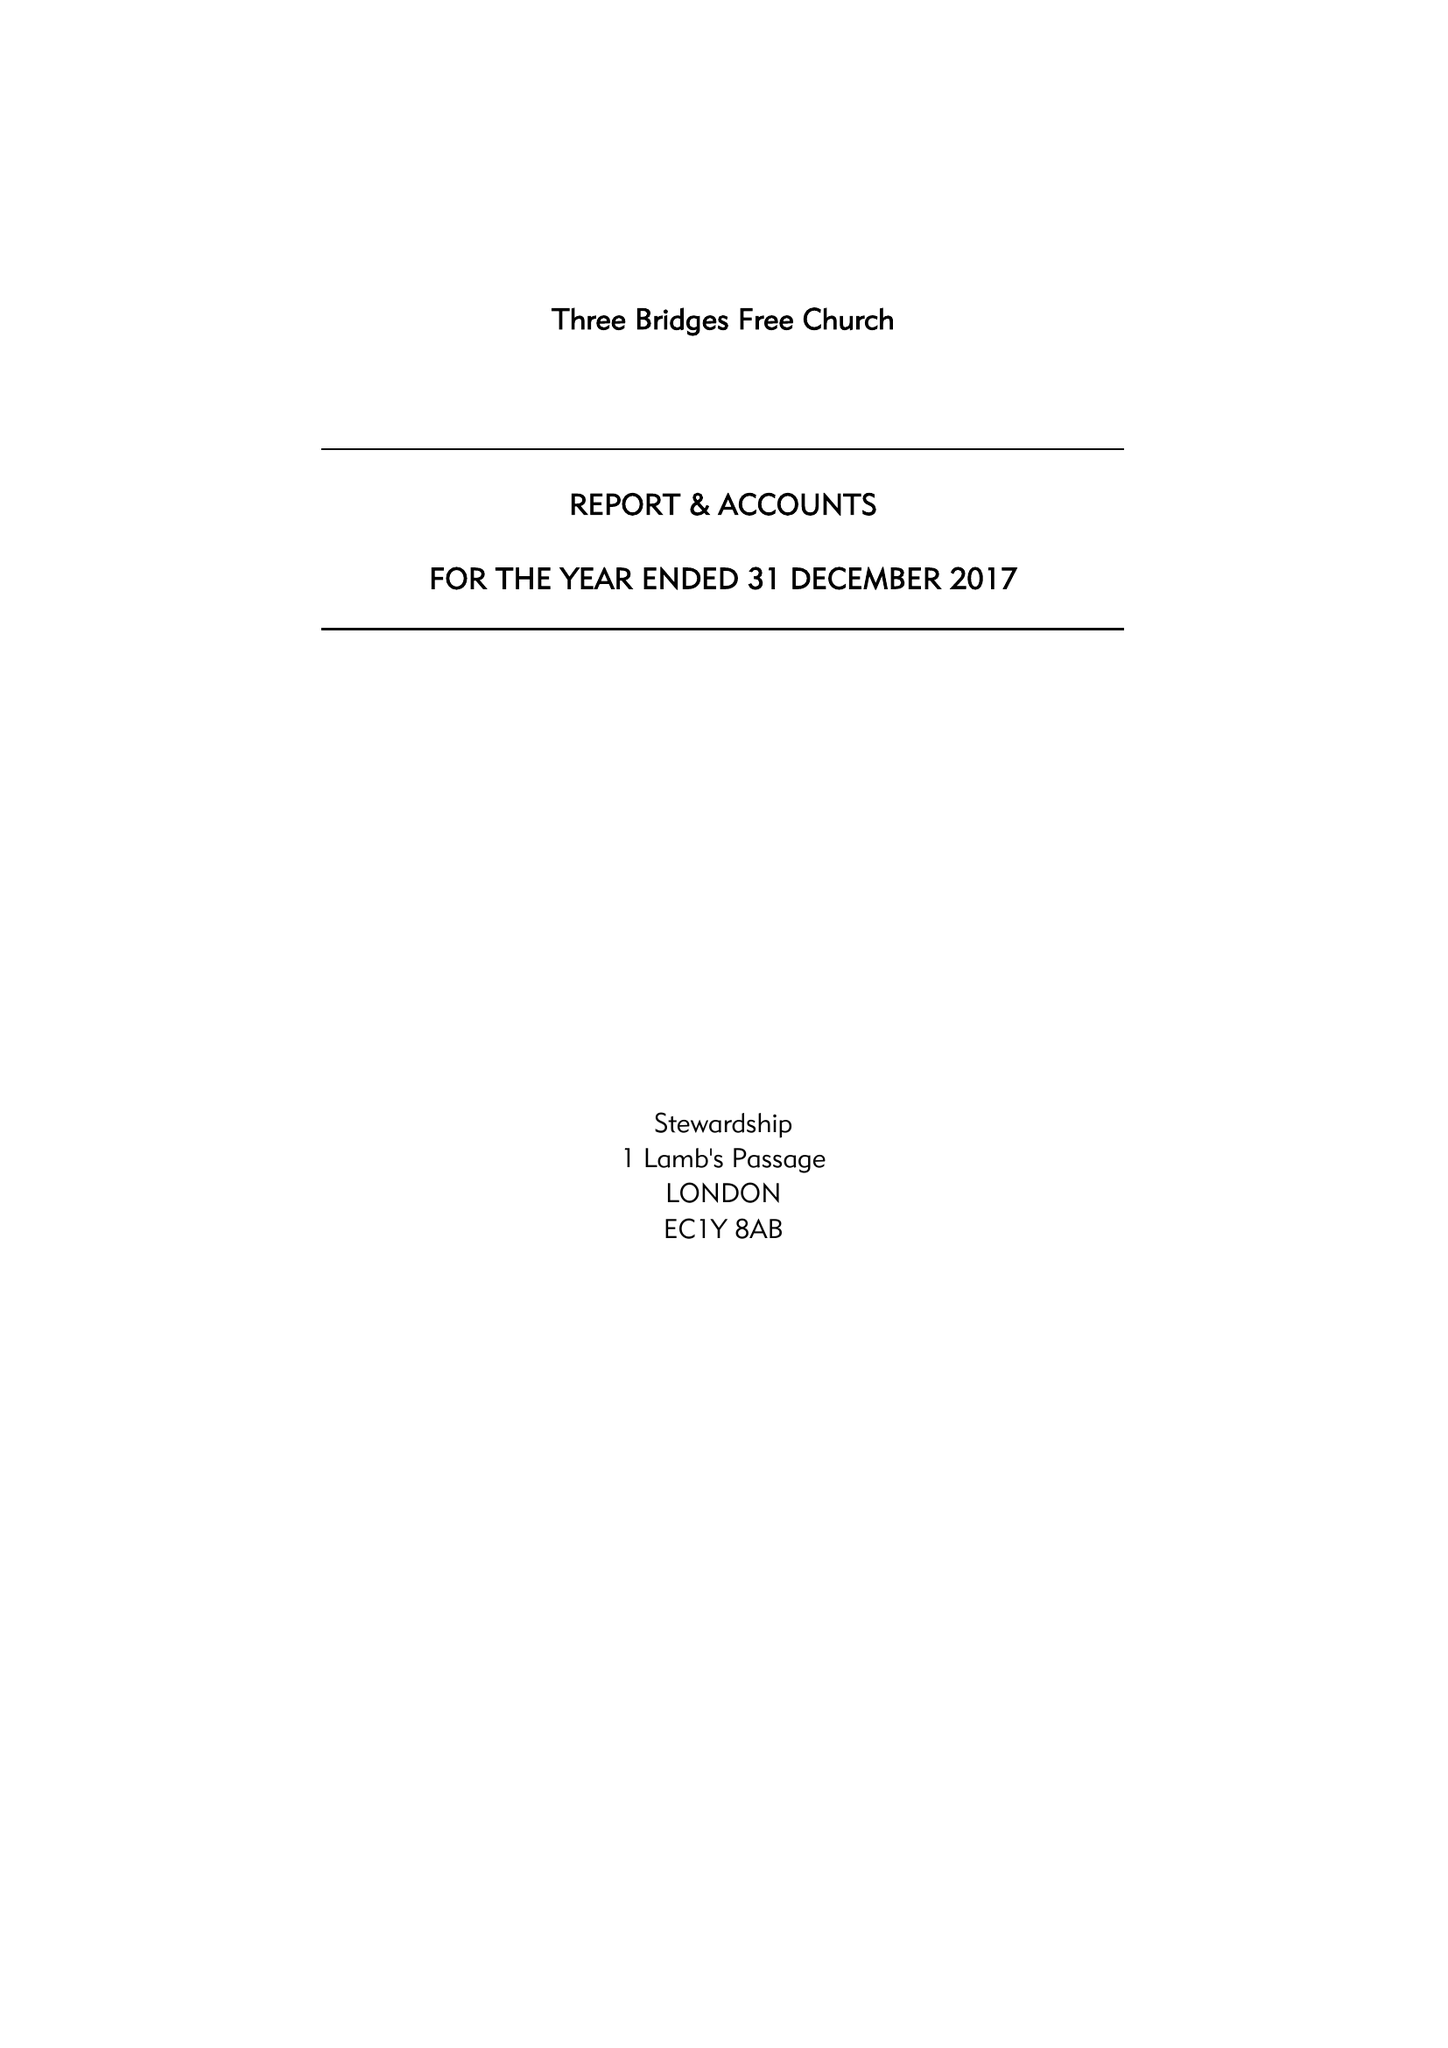What is the value for the spending_annually_in_british_pounds?
Answer the question using a single word or phrase. 232554.00 